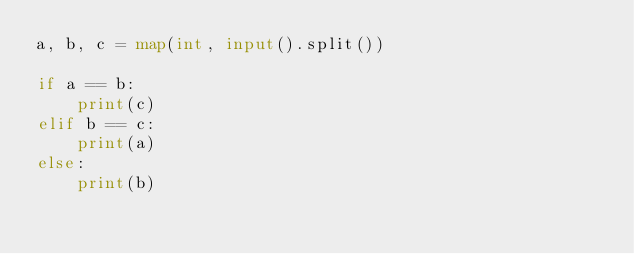Convert code to text. <code><loc_0><loc_0><loc_500><loc_500><_Python_>a, b, c = map(int, input().split())

if a == b:
    print(c)
elif b == c:
    print(a)
else:
    print(b)</code> 